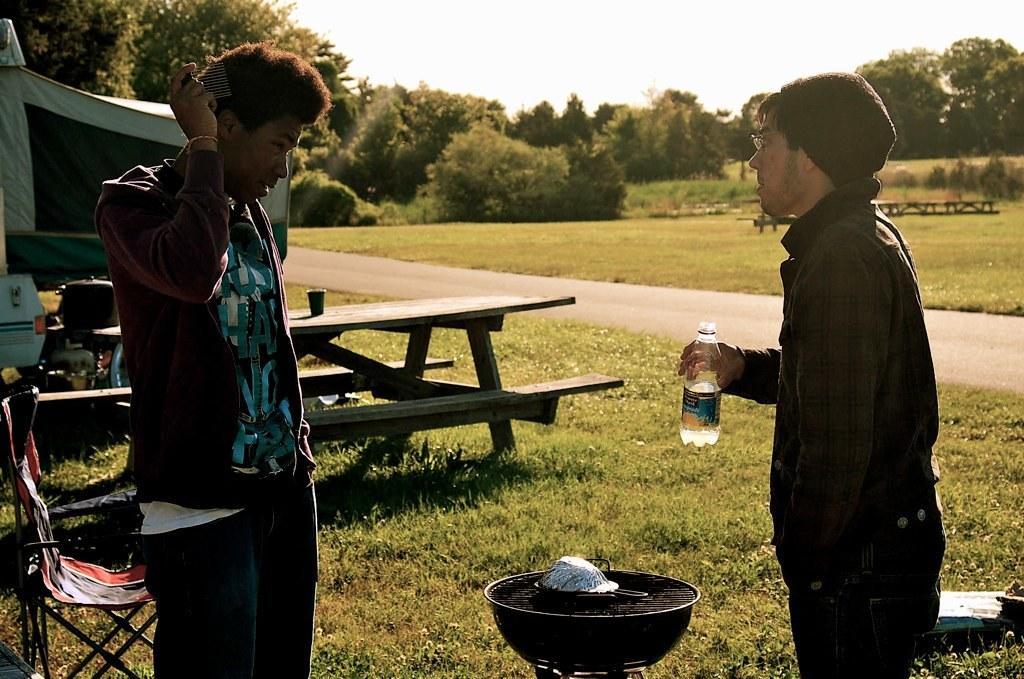Please provide a concise description of this image. This is a image of out side of the city and there are the two persons standing on the grass and left side there is a chair and on the middle i can see a pan a person on the right side holding a bottle on his hand and on the back ground i can see a trees and there is a sky visible ,on the middle i can see a table ,on the table i can see a glass and there is a road. 